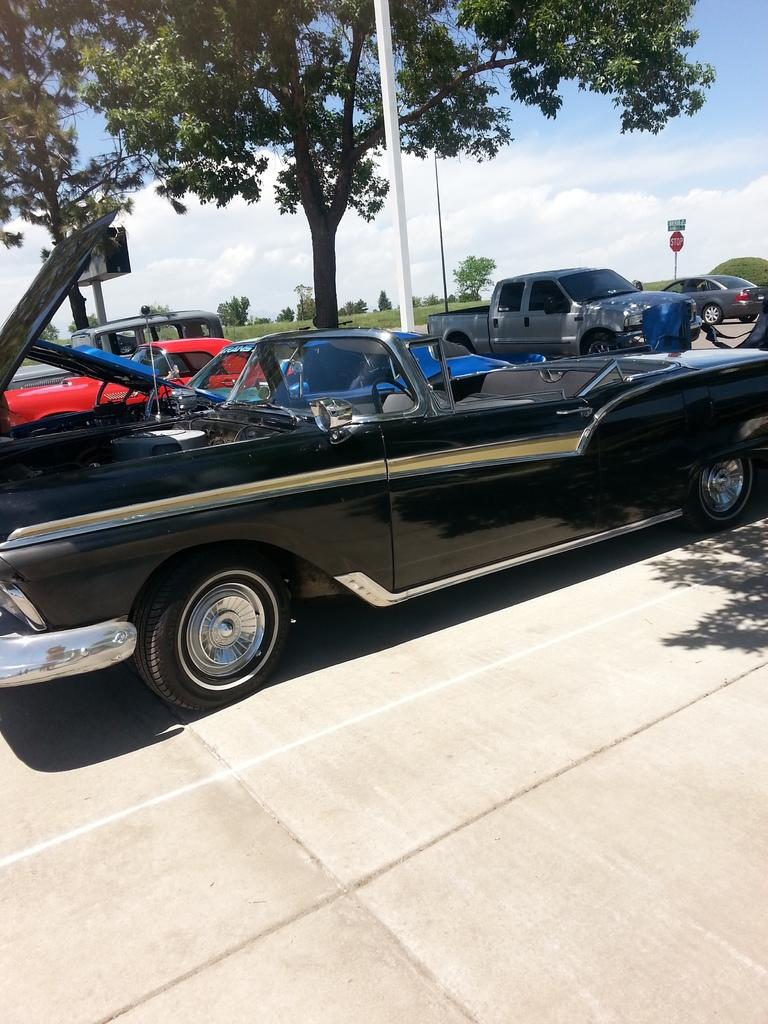What is the main subject in the center of the image? There is a car in the center of the image. Where is the car located? The car is on the road. What can be seen in the background of the image? There are cars, a sign board, a pole, trees, plants, and the sky visible in the background. What is the condition of the sky in the image? The sky is visible in the background, and clouds are present. What type of sleet can be seen falling from the sky in the image? There is no sleet present in the image; only clouds are visible in the sky. What kind of flag is attached to the pole in the image? There is no flag present in the image; only a pole is visible in the background. 